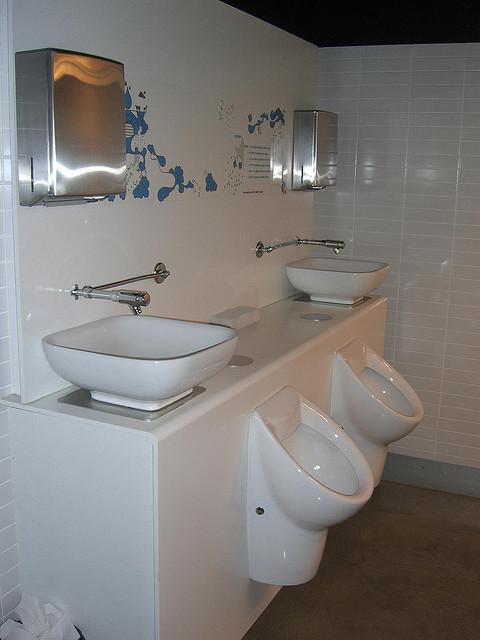How many urinals are there?
Give a very brief answer. 2. How many objects would require running water?
Give a very brief answer. 4. How many sinks are there?
Give a very brief answer. 2. How many sinks are here?
Give a very brief answer. 2. How many people commonly use this bathroom?
Give a very brief answer. 2. How many people are in this photo?
Give a very brief answer. 0. 